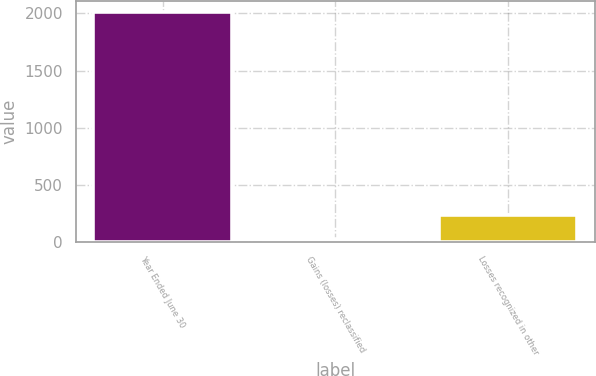<chart> <loc_0><loc_0><loc_500><loc_500><bar_chart><fcel>Year Ended June 30<fcel>Gains (losses) reclassified<fcel>Losses recognized in other<nl><fcel>2012<fcel>27<fcel>231<nl></chart> 